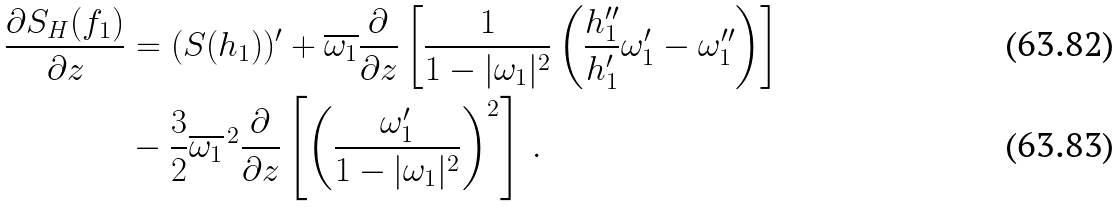<formula> <loc_0><loc_0><loc_500><loc_500>\frac { \partial S _ { H } ( f _ { 1 } ) } { \partial z } & = ( S ( h _ { 1 } ) ) ^ { \prime } + \overline { \omega _ { 1 } } \frac { \partial } { \partial z } \left [ \frac { 1 } { 1 - | \omega _ { 1 } | ^ { 2 } } \left ( \frac { h ^ { \prime \prime } _ { 1 } } { h ^ { \prime } _ { 1 } } \omega ^ { \prime } _ { 1 } - \omega ^ { \prime \prime } _ { 1 } \right ) \right ] \\ & - \frac { 3 } { 2 } \overline { \omega _ { 1 } } ^ { \, 2 } \frac { \partial } { \partial z } \left [ \left ( \frac { \omega ^ { \prime } _ { 1 } } { 1 - | \omega _ { 1 } | ^ { 2 } } \right ) ^ { 2 } \right ] \, .</formula> 